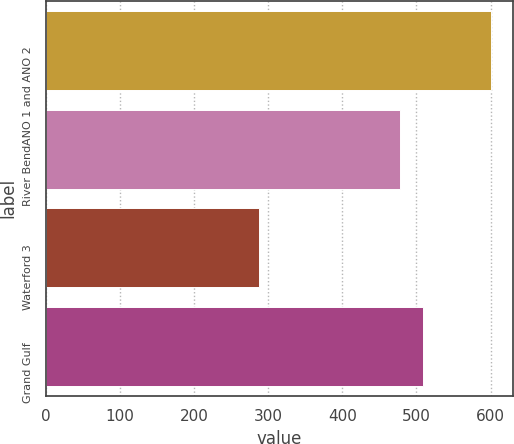<chart> <loc_0><loc_0><loc_500><loc_500><bar_chart><fcel>ANO 1 and ANO 2<fcel>River Bend<fcel>Waterford 3<fcel>Grand Gulf<nl><fcel>600.6<fcel>477.4<fcel>287.4<fcel>508.72<nl></chart> 